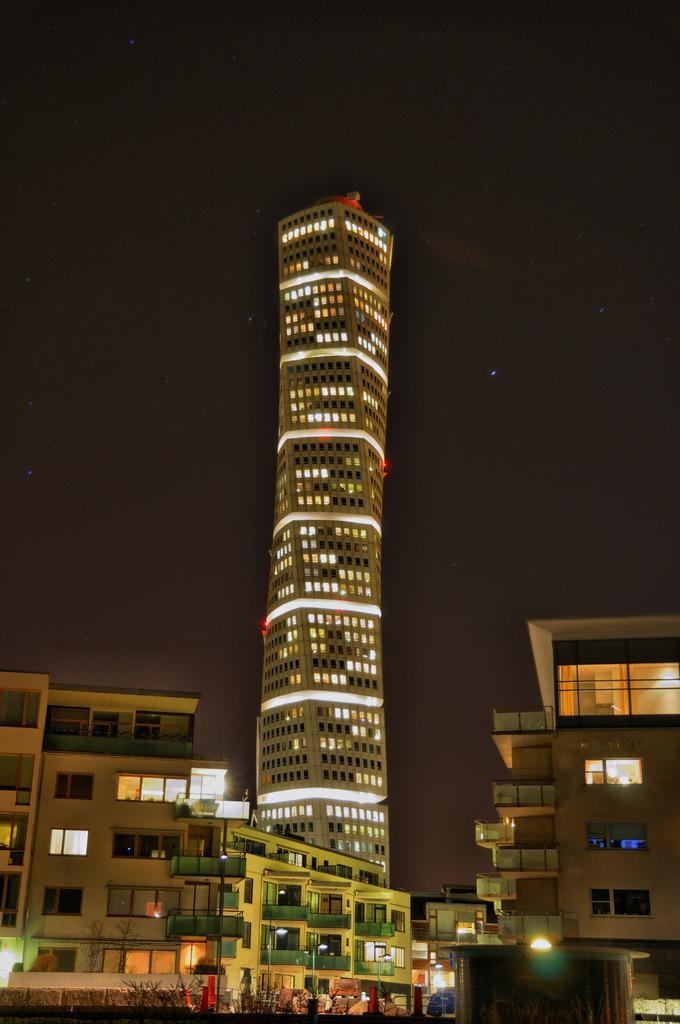In one or two sentences, can you explain what this image depicts? In the image we can see the buildings, tower building and windows of the building. Here we can see the lights and the sky. 